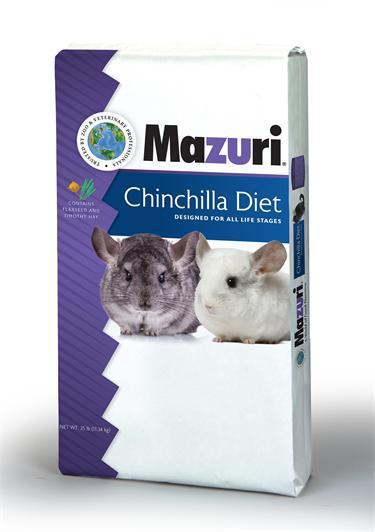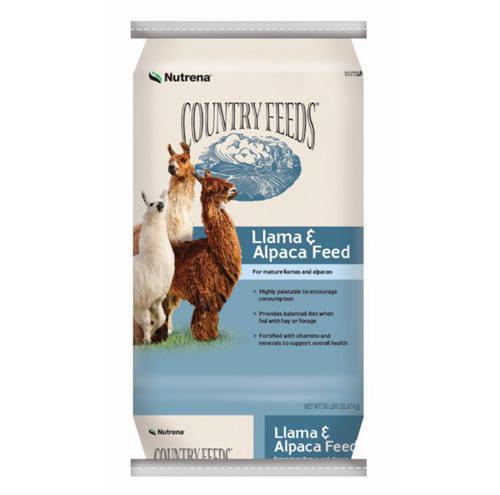The first image is the image on the left, the second image is the image on the right. Assess this claim about the two images: "One image shows loose pet food pellets and another image shows a bag of animal food.". Correct or not? Answer yes or no. No. The first image is the image on the left, the second image is the image on the right. Analyze the images presented: Is the assertion "The left image contains one bag of food with two hooved animals on the front of the package, and the right image contains a mass of small bits of animal feed." valid? Answer yes or no. No. 